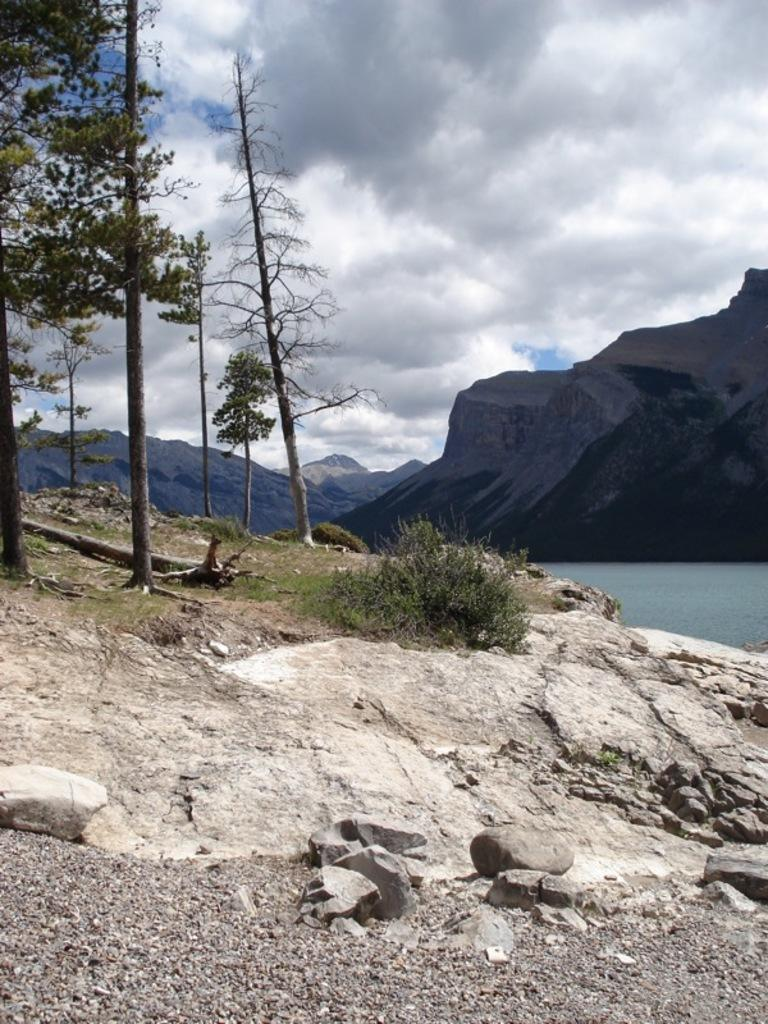What type of natural feature can be seen in the image? There is a river in the image. What other natural elements are present in the image? There are trees, grass, mountains, and stones visible in the image. What is the condition of the sky in the image? The sky is cloudy in the image. Can you see a girl riding a train in the image? There is no train or girl present in the image. What is the reason for the stop in the image? There is no stop or indication of any activity being halted in the image. 